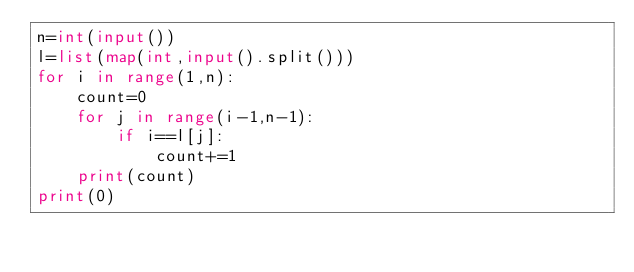<code> <loc_0><loc_0><loc_500><loc_500><_Python_>n=int(input())
l=list(map(int,input().split()))
for i in range(1,n):
    count=0
    for j in range(i-1,n-1):
        if i==l[j]:
            count+=1
    print(count)
print(0)
</code> 